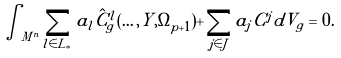<formula> <loc_0><loc_0><loc_500><loc_500>\int _ { M ^ { n } } \sum _ { l \in L _ { * } } a _ { l } \hat { C } ^ { l } _ { g } ( \dots , Y , \Omega _ { p + 1 } ) + \sum _ { j \in J } a _ { j } C ^ { j } d V _ { g } = 0 .</formula> 